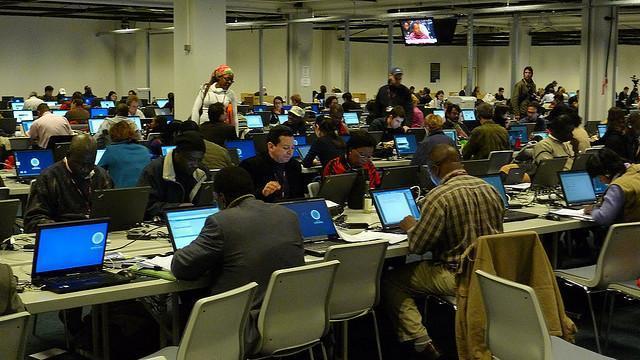How many empty chairs?
Give a very brief answer. 4. How many laptops are in the picture?
Give a very brief answer. 3. How many chairs are there?
Give a very brief answer. 7. How many people are there?
Give a very brief answer. 8. How many dogs are there in the image?
Give a very brief answer. 0. 